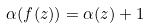<formula> <loc_0><loc_0><loc_500><loc_500>\alpha ( f ( z ) ) = \alpha ( z ) + 1</formula> 